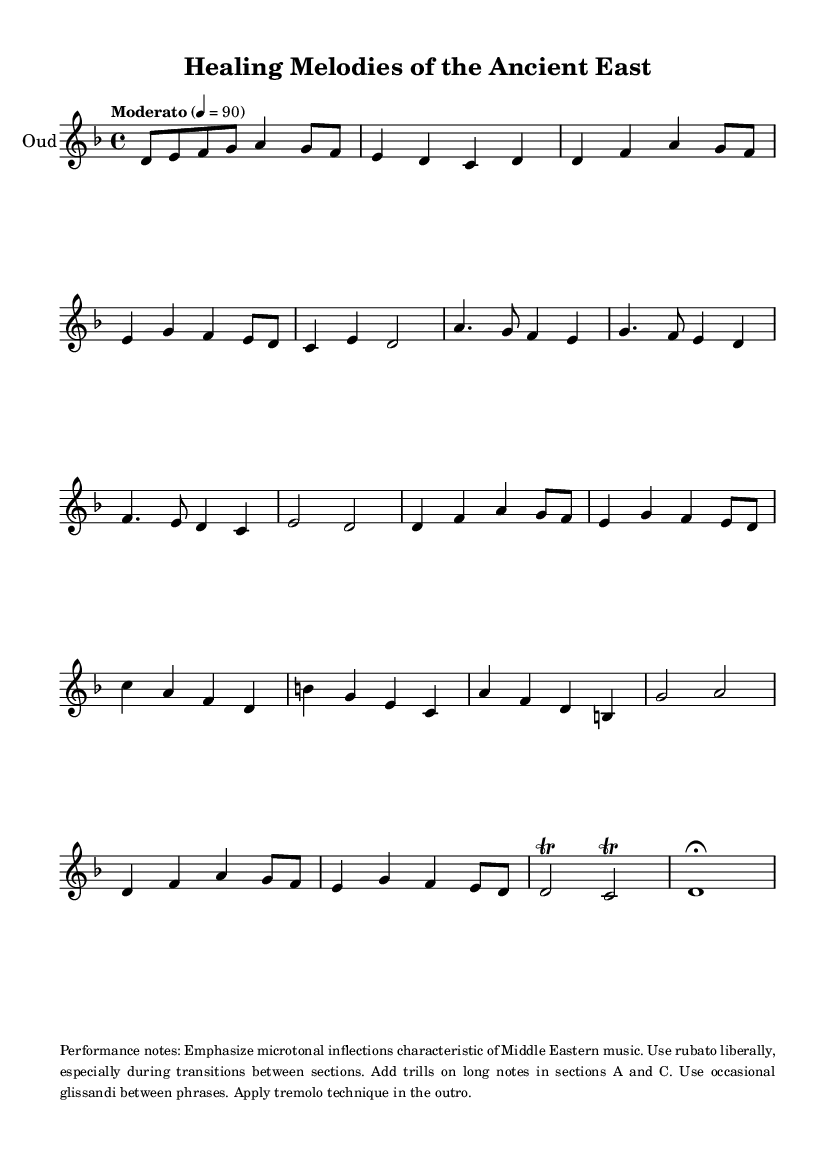What is the key signature of this music? The key signature is D minor, which has one flat (B flat). You can see this indicated at the beginning of the sheet music after the clef symbol.
Answer: D minor What is the time signature of this piece? The time signature is 4/4, which is indicated at the beginning of the score. This means there are four beats in each measure and the quarter note gets one beat.
Answer: 4/4 What is the tempo marking? The tempo marking is "Moderato," which indicates a moderate speed. It's noted at the beginning of the score along with a metronome marking of 90 beats per minute.
Answer: Moderato In which section is the longest note value found? The longest note value appears in the outro section, where there is a whole note (d'1) at the end of the music. This is the longest duration indicated in the piece.
Answer: Outro How many sections are there in this piece? The piece consists of six named sections: Intro, A, B, A' (shortened), C, and A'' (shortened), and an abbreviated outro. Each section is marked clearly in the music.
Answer: Six What performance technique is emphasized during the transitions? Rubato is emphasized during transitions. This is a performance technique allowing for flexible timing and expressive phrasing, as specified in the performance notes.
Answer: Rubato What microtonal inflections are characteristic of this music type? The performance notes specify to emphasize microtonal inflections, which are typical in Middle Eastern music. These inflections can usually be seen in the decorative notes and techniques suggested in the performance notes.
Answer: Microtonal inflections 